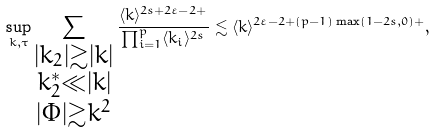<formula> <loc_0><loc_0><loc_500><loc_500>\sup _ { k , \tau } \sum _ { \substack { | k _ { 2 } | \gtrsim | k | \\ k _ { 2 } ^ { * } \ll | k | \\ | \Phi | \gtrsim k ^ { 2 } } } \frac { \langle k \rangle ^ { 2 s + 2 \varepsilon - 2 + } } { \prod _ { i = 1 } ^ { p } \langle k _ { i } \rangle ^ { 2 s } } \lesssim \langle k \rangle ^ { 2 \varepsilon - 2 + ( p - 1 ) \max ( 1 - 2 s , 0 ) + } ,</formula> 